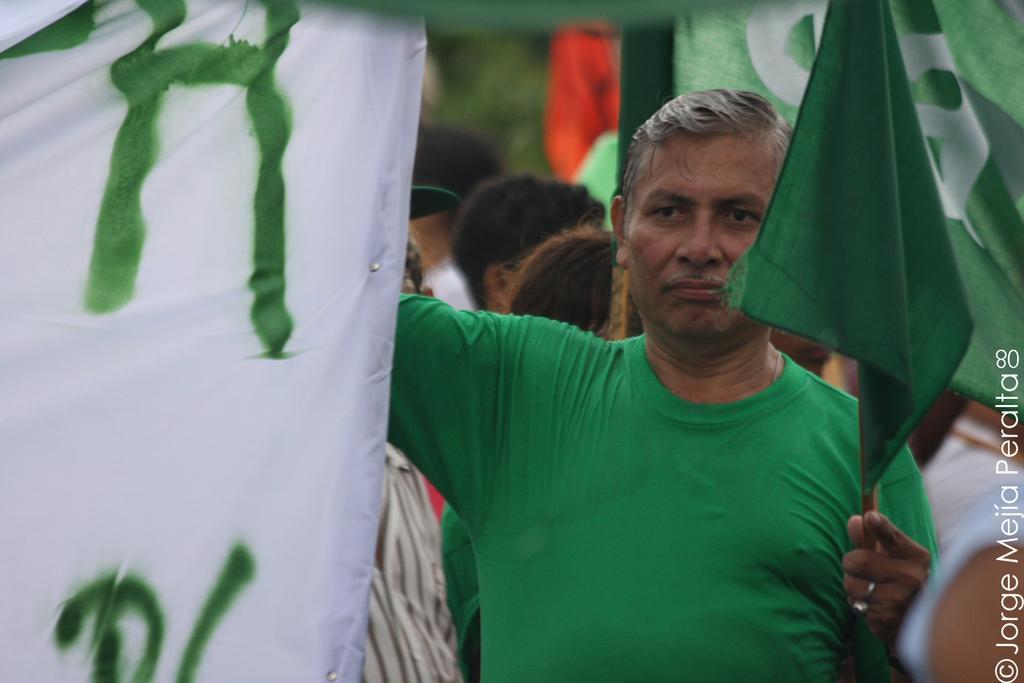How would you summarize this image in a sentence or two? In this image there is a person with green t shirt holding a green color flag. Image also consists of many people and also flags. There is also a logo. 